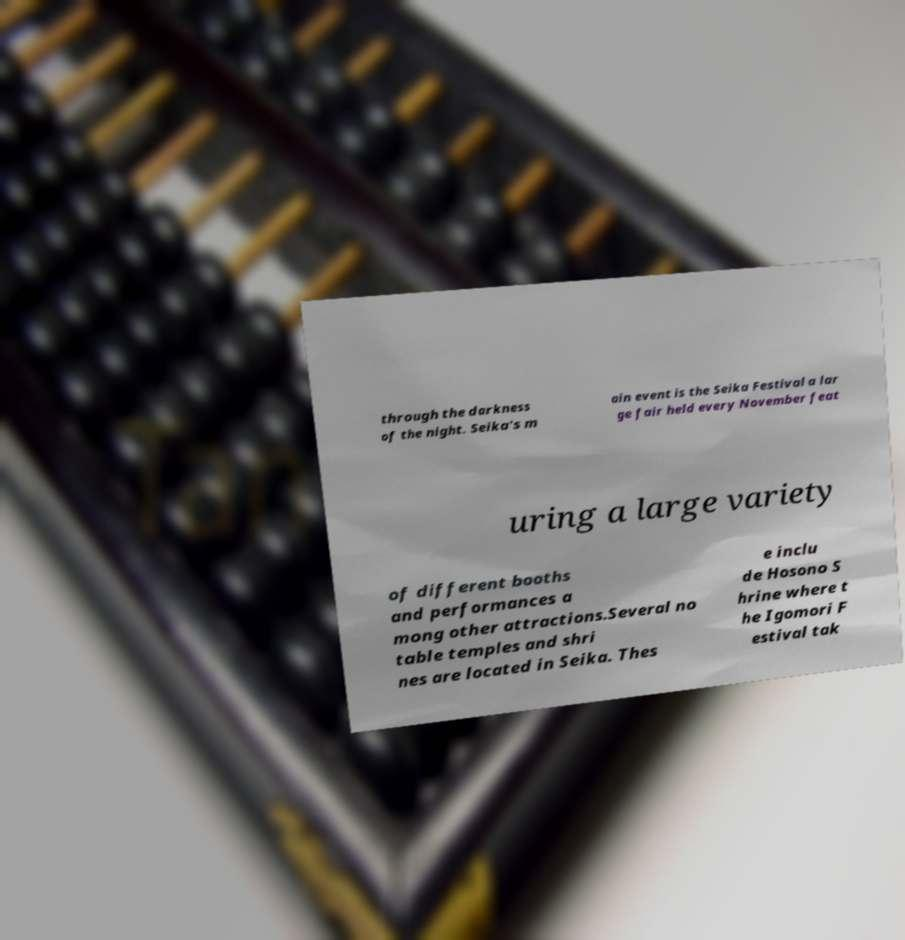For documentation purposes, I need the text within this image transcribed. Could you provide that? through the darkness of the night. Seika's m ain event is the Seika Festival a lar ge fair held every November feat uring a large variety of different booths and performances a mong other attractions.Several no table temples and shri nes are located in Seika. Thes e inclu de Hosono S hrine where t he Igomori F estival tak 